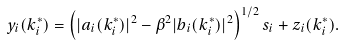Convert formula to latex. <formula><loc_0><loc_0><loc_500><loc_500>y _ { i } ( k _ { i } ^ { * } ) = \left ( | a _ { i } ( k _ { i } ^ { * } ) | ^ { 2 } - \beta ^ { 2 } | b _ { i } ( k ^ { * } _ { i } ) | ^ { 2 } \right ) ^ { 1 / 2 } s _ { i } + z _ { i } ( k _ { i } ^ { * } ) .</formula> 